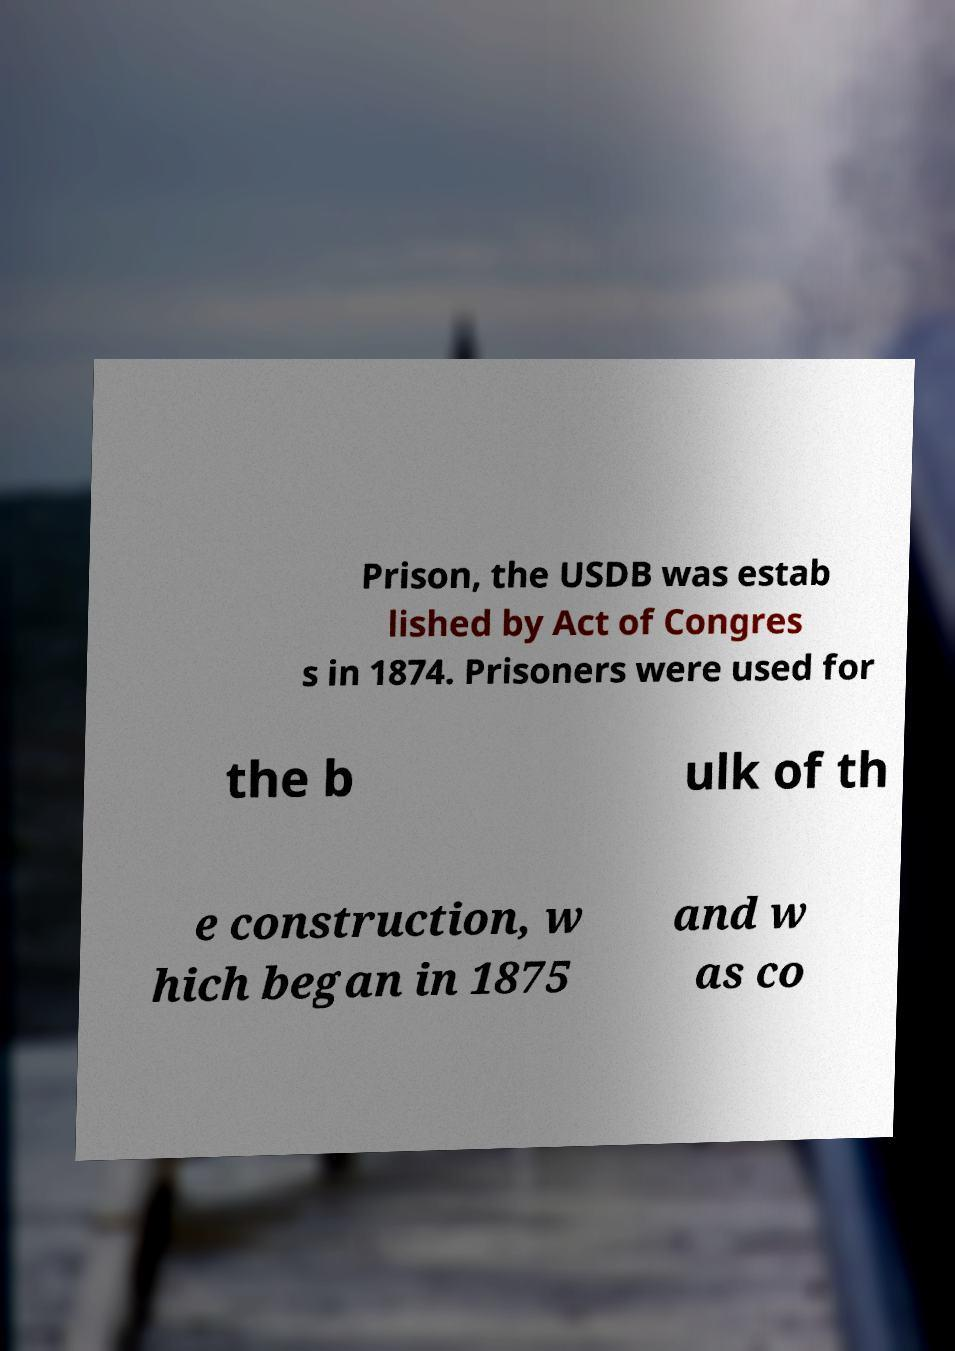Could you assist in decoding the text presented in this image and type it out clearly? Prison, the USDB was estab lished by Act of Congres s in 1874. Prisoners were used for the b ulk of th e construction, w hich began in 1875 and w as co 